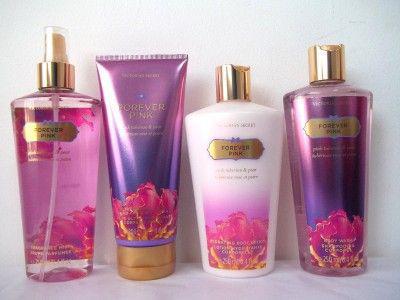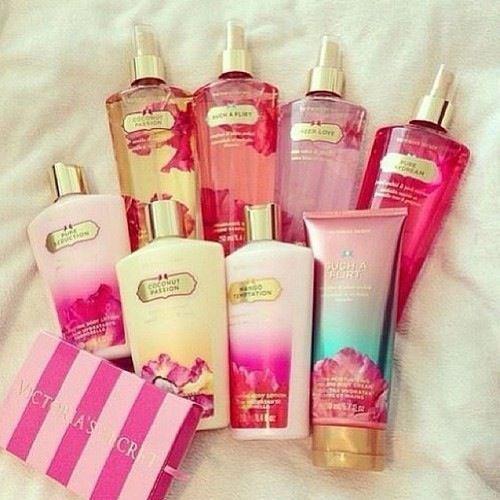The first image is the image on the left, the second image is the image on the right. Examine the images to the left and right. Is the description "In one of the images there are seven containers lined up in a V shape." accurate? Answer yes or no. No. 